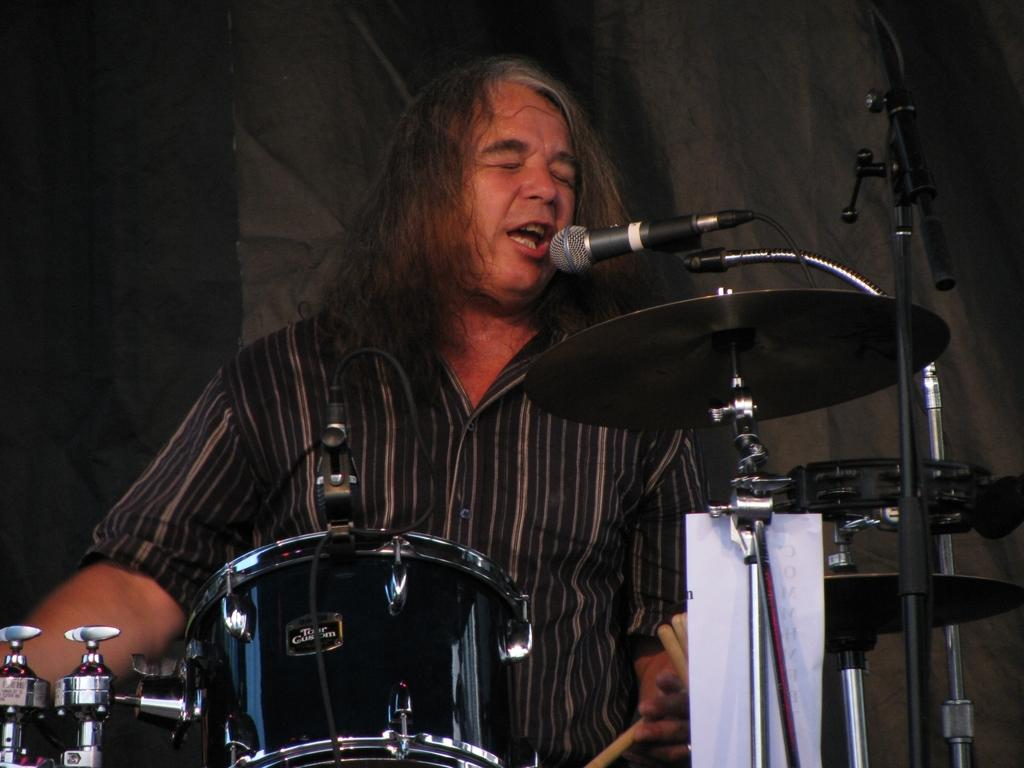Who or what is present in the image? There is a person in the image. What else can be seen in the image besides the person? There are musical instruments and a microphone in the image. What type of plantation is visible in the image? There is no plantation present in the image. 